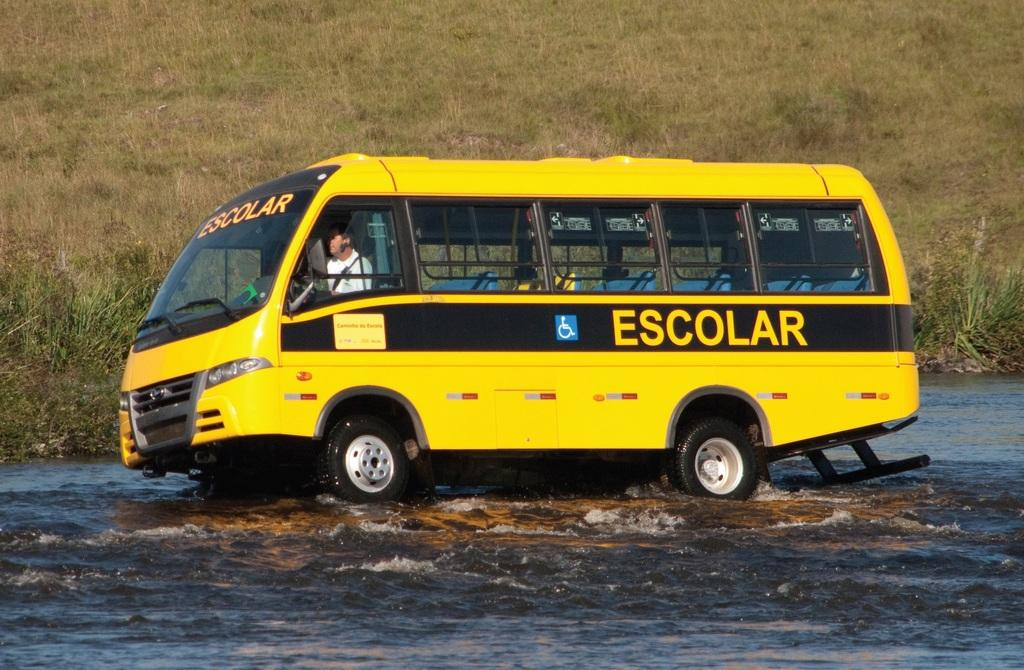<image>
Give a short and clear explanation of the subsequent image. The yellow bus Escolar is driving through high water. 